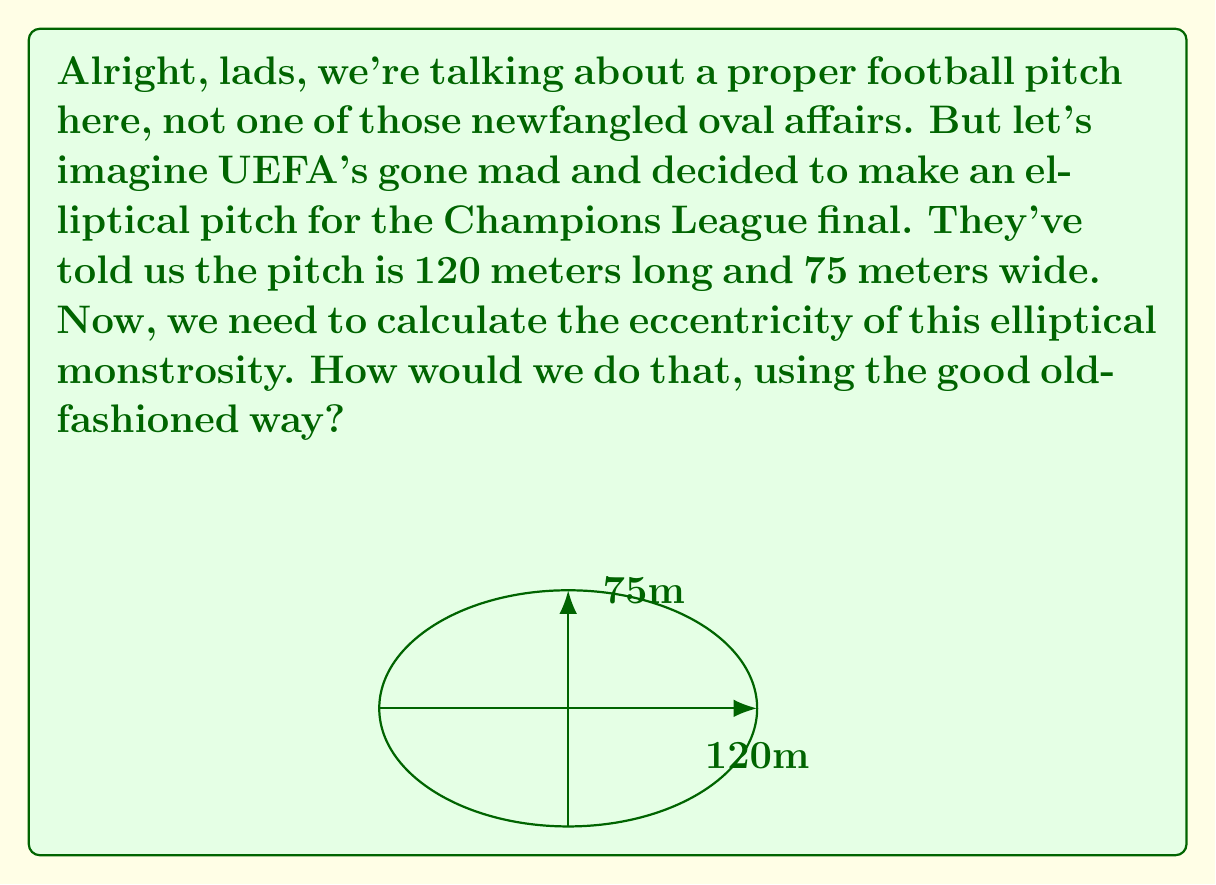Could you help me with this problem? Right, let's break this down step by step, just like analyzing a classic 4-4-2 formation:

1) First, we need to identify the semi-major and semi-minor axes of our elliptical pitch:
   Semi-major axis (a) = 120/2 = 60 meters
   Semi-minor axis (b) = 75/2 = 37.5 meters

2) Now, the eccentricity (e) of an ellipse is given by the formula:

   $$e = \sqrt{1 - \frac{b^2}{a^2}}$$

3) Let's substitute our values:

   $$e = \sqrt{1 - \frac{37.5^2}{60^2}}$$

4) Simplify inside the parentheses:

   $$e = \sqrt{1 - \frac{1406.25}{3600}}$$

5) Divide:

   $$e = \sqrt{1 - 0.390625}$$

6) Subtract:

   $$e = \sqrt{0.609375}$$

7) Take the square root:

   $$e \approx 0.7806$$

And there you have it, as clear as a well-executed offside trap!
Answer: $e \approx 0.7806$ 